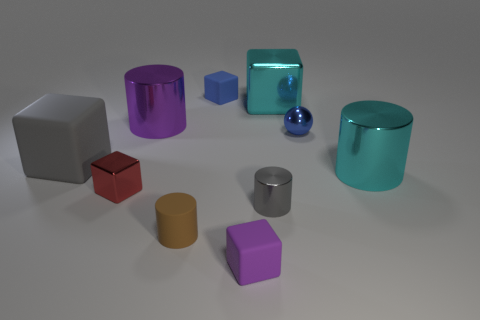Subtract all large blocks. How many blocks are left? 3 Subtract 3 blocks. How many blocks are left? 2 Subtract all blue cubes. How many cubes are left? 4 Subtract all yellow cylinders. Subtract all purple balls. How many cylinders are left? 4 Subtract all spheres. How many objects are left? 9 Subtract 0 cyan spheres. How many objects are left? 10 Subtract all brown cylinders. Subtract all purple metal cylinders. How many objects are left? 8 Add 7 big matte cubes. How many big matte cubes are left? 8 Add 1 large cyan shiny things. How many large cyan shiny things exist? 3 